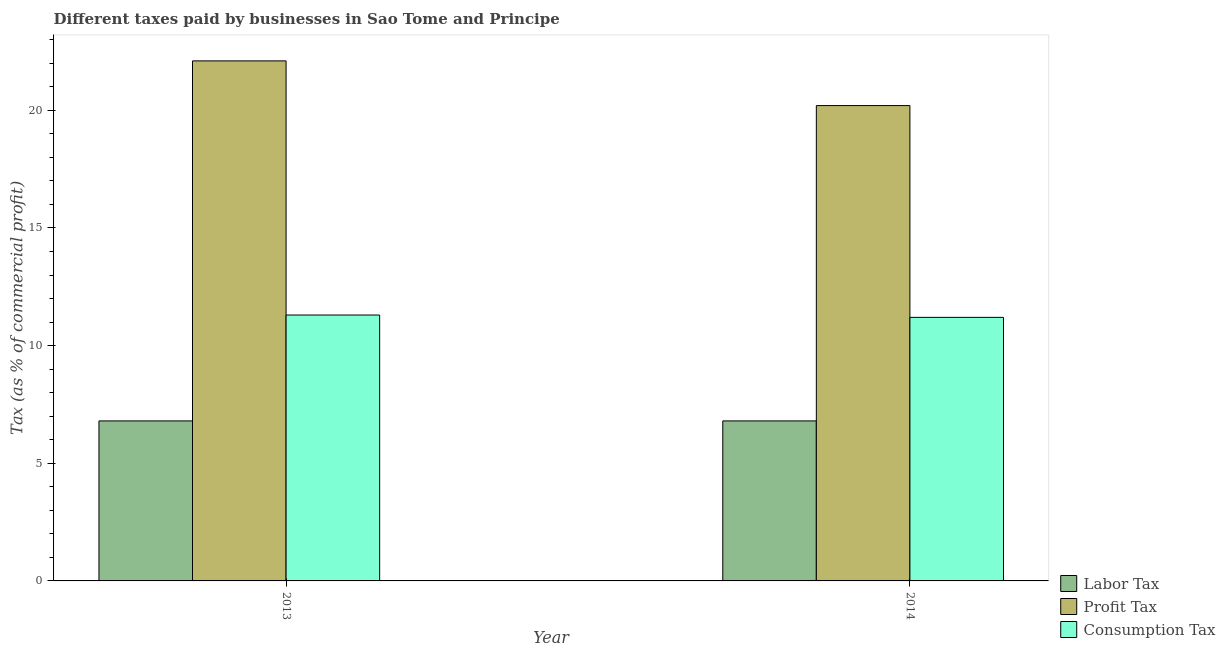How many different coloured bars are there?
Your answer should be very brief. 3. How many groups of bars are there?
Your answer should be compact. 2. Are the number of bars on each tick of the X-axis equal?
Provide a succinct answer. Yes. How many bars are there on the 1st tick from the left?
Make the answer very short. 3. What is the label of the 2nd group of bars from the left?
Keep it short and to the point. 2014. What is the percentage of profit tax in 2013?
Offer a terse response. 22.1. Across all years, what is the minimum percentage of profit tax?
Provide a short and direct response. 20.2. In which year was the percentage of consumption tax maximum?
Give a very brief answer. 2013. What is the difference between the percentage of profit tax in 2013 and that in 2014?
Keep it short and to the point. 1.9. What is the difference between the percentage of labor tax in 2013 and the percentage of consumption tax in 2014?
Provide a succinct answer. 0. What is the average percentage of labor tax per year?
Your answer should be very brief. 6.8. What is the ratio of the percentage of labor tax in 2013 to that in 2014?
Your response must be concise. 1. Is the percentage of labor tax in 2013 less than that in 2014?
Your answer should be very brief. No. What does the 2nd bar from the left in 2013 represents?
Make the answer very short. Profit Tax. What does the 2nd bar from the right in 2014 represents?
Provide a short and direct response. Profit Tax. Is it the case that in every year, the sum of the percentage of labor tax and percentage of profit tax is greater than the percentage of consumption tax?
Offer a terse response. Yes. How many bars are there?
Offer a very short reply. 6. Are all the bars in the graph horizontal?
Your answer should be compact. No. How many years are there in the graph?
Provide a short and direct response. 2. Are the values on the major ticks of Y-axis written in scientific E-notation?
Your response must be concise. No. How are the legend labels stacked?
Offer a very short reply. Vertical. What is the title of the graph?
Keep it short and to the point. Different taxes paid by businesses in Sao Tome and Principe. Does "Errors" appear as one of the legend labels in the graph?
Keep it short and to the point. No. What is the label or title of the Y-axis?
Offer a very short reply. Tax (as % of commercial profit). What is the Tax (as % of commercial profit) in Profit Tax in 2013?
Offer a terse response. 22.1. What is the Tax (as % of commercial profit) of Labor Tax in 2014?
Make the answer very short. 6.8. What is the Tax (as % of commercial profit) in Profit Tax in 2014?
Ensure brevity in your answer.  20.2. What is the Tax (as % of commercial profit) of Consumption Tax in 2014?
Provide a short and direct response. 11.2. Across all years, what is the maximum Tax (as % of commercial profit) in Labor Tax?
Offer a very short reply. 6.8. Across all years, what is the maximum Tax (as % of commercial profit) of Profit Tax?
Provide a short and direct response. 22.1. Across all years, what is the maximum Tax (as % of commercial profit) in Consumption Tax?
Make the answer very short. 11.3. Across all years, what is the minimum Tax (as % of commercial profit) in Labor Tax?
Make the answer very short. 6.8. Across all years, what is the minimum Tax (as % of commercial profit) in Profit Tax?
Offer a very short reply. 20.2. What is the total Tax (as % of commercial profit) of Labor Tax in the graph?
Offer a terse response. 13.6. What is the total Tax (as % of commercial profit) of Profit Tax in the graph?
Make the answer very short. 42.3. What is the total Tax (as % of commercial profit) in Consumption Tax in the graph?
Make the answer very short. 22.5. What is the difference between the Tax (as % of commercial profit) of Labor Tax in 2013 and that in 2014?
Offer a very short reply. 0. What is the difference between the Tax (as % of commercial profit) in Profit Tax in 2013 and that in 2014?
Give a very brief answer. 1.9. What is the difference between the Tax (as % of commercial profit) in Labor Tax in 2013 and the Tax (as % of commercial profit) in Profit Tax in 2014?
Offer a terse response. -13.4. What is the average Tax (as % of commercial profit) of Profit Tax per year?
Make the answer very short. 21.15. What is the average Tax (as % of commercial profit) of Consumption Tax per year?
Your answer should be compact. 11.25. In the year 2013, what is the difference between the Tax (as % of commercial profit) of Labor Tax and Tax (as % of commercial profit) of Profit Tax?
Your answer should be very brief. -15.3. In the year 2014, what is the difference between the Tax (as % of commercial profit) of Labor Tax and Tax (as % of commercial profit) of Profit Tax?
Your answer should be compact. -13.4. In the year 2014, what is the difference between the Tax (as % of commercial profit) in Labor Tax and Tax (as % of commercial profit) in Consumption Tax?
Make the answer very short. -4.4. What is the ratio of the Tax (as % of commercial profit) of Labor Tax in 2013 to that in 2014?
Offer a very short reply. 1. What is the ratio of the Tax (as % of commercial profit) of Profit Tax in 2013 to that in 2014?
Provide a short and direct response. 1.09. What is the ratio of the Tax (as % of commercial profit) in Consumption Tax in 2013 to that in 2014?
Offer a terse response. 1.01. What is the difference between the highest and the second highest Tax (as % of commercial profit) of Profit Tax?
Keep it short and to the point. 1.9. What is the difference between the highest and the lowest Tax (as % of commercial profit) of Labor Tax?
Keep it short and to the point. 0. 